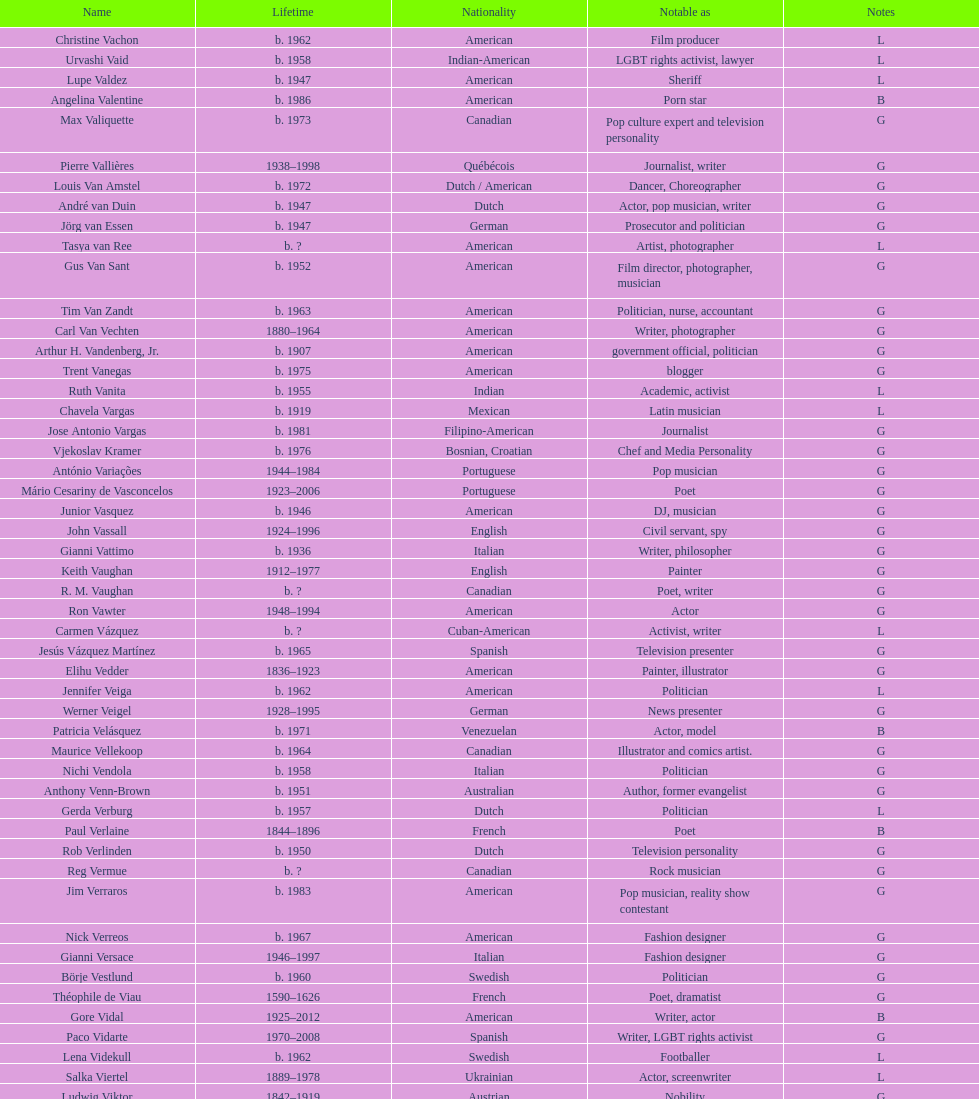In which nationality can the highest number of famous poets be found? French. 